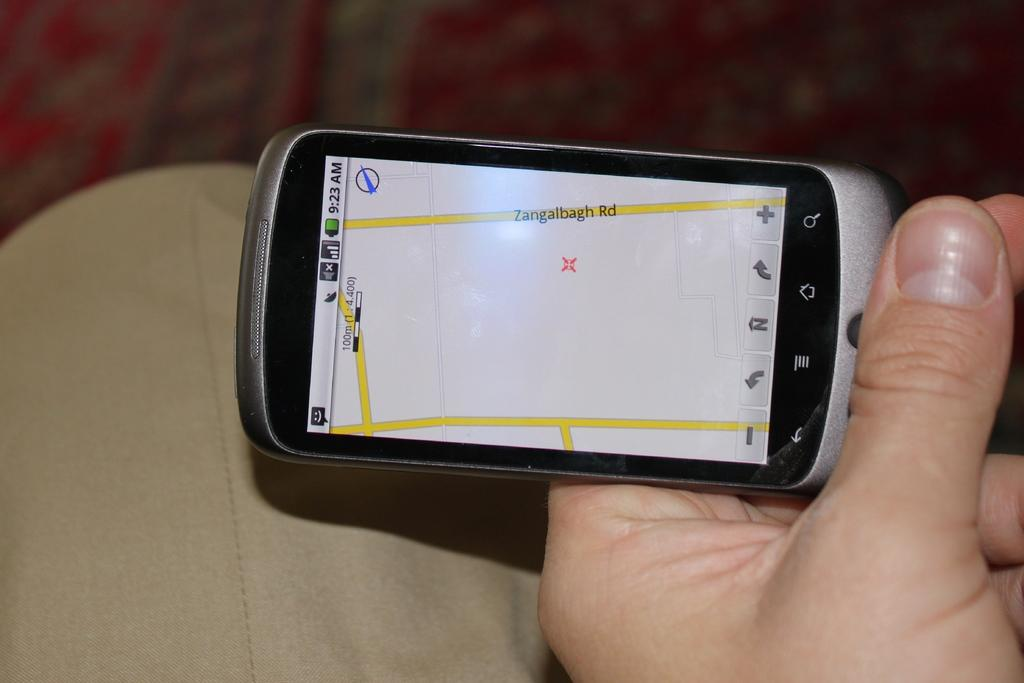Provide a one-sentence caption for the provided image. A person is looking at Zangalbagh Road on the map on their phone. 